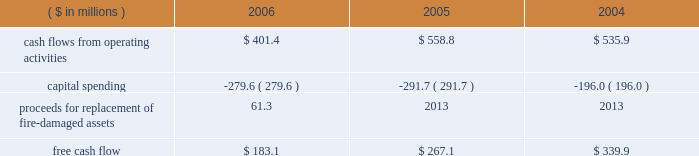Page 29 of 98 in connection with the internal revenue service 2019s ( irs ) examination of ball 2019s consolidated income tax returns for the tax years 2000 through 2004 , the irs has proposed to disallow ball 2019s deductions of interest expense incurred on loans under a company-owned life insurance plan that has been in place for more than 20 years .
Ball believes that its interest deductions will be sustained as filed and , therefore , no provision for loss has been recorded .
The total potential liability for the audit years 1999 through 2004 , unaudited year 2005 and an estimate of the impact on 2006 is approximately $ 31 million , excluding related interest .
The irs has withdrawn its proposed adjustments for any penalties .
See note 13 accompanying the consolidated financial statements within item 8 of this annual report .
Results of equity affiliates equity in the earnings of affiliates in 2006 is primarily attributable to our 50 percent ownership in packaging investments in the u.s .
And brazil .
Earnings in 2004 included the results of a minority-owned aerospace business , which was sold in october 2005 , and a $ 15.2 million loss representing ball 2019s share of a provision for doubtful accounts relating to its 35 percent interest in sanshui jfp ( discussed above in 201cmetal beverage packaging , europe/asia 201d ) .
After consideration of the prc loss , earnings were $ 14.7 million in 2006 compared to $ 15.5 million in 2005 and $ 15.8 million in 2004 .
Critical and significant accounting policies and new accounting pronouncements for information regarding the company 2019s critical and significant accounting policies , as well as recent accounting pronouncements , see note 1 to the consolidated financial statements within item 8 of this report .
Financial condition , liquidity and capital resources cash flows and capital expenditures cash flows from operating activities were $ 401.4 million in 2006 compared to $ 558.8 million in 2005 and $ 535.9 million in 2004 .
Management internally uses a free cash flow measure : ( 1 ) to evaluate the company 2019s operating results , ( 2 ) for planning purposes , ( 3 ) to evaluate strategic investments and ( 4 ) to evaluate the company 2019s ability to incur and service debt .
Free cash flow is not a defined term under u.s .
Generally accepted accounting principles , and it should not be inferred that the entire free cash flow amount is available for discretionary expenditures .
The company defines free cash flow as cash flow from operating activities less additions to property , plant and equipment ( capital spending ) .
Free cash flow is typically derived directly from the company 2019s cash flow statements ; however , it may be adjusted for items that affect comparability between periods .
An example of such an item included in 2006 is the property insurance proceeds for the replacement of the fire-damaged assets in our hassloch , germany , plant , which is included in capital spending amounts .
Based on this , our consolidated free cash flow is summarized as follows: .
Cash flows from operating activities in 2006 were negatively affected by higher cash pension funding and higher working capital levels compared to the prior year .
The higher working capital was a combination of higher than planned raw material inventory levels , higher income tax payments and higher accounts receivable balances , the latter resulting primarily from the repayment of a portion of the accounts receivable securitization program and late payments from customers in europe .
Management expects the increase in working capital to be temporary and that working capital levels will return to normal levels by the end of the first half of 2007. .
What was the difference in free cash flow between 2005 and 2006 in millions? 
Computations: (183.1 - 267.1)
Answer: -84.0. 